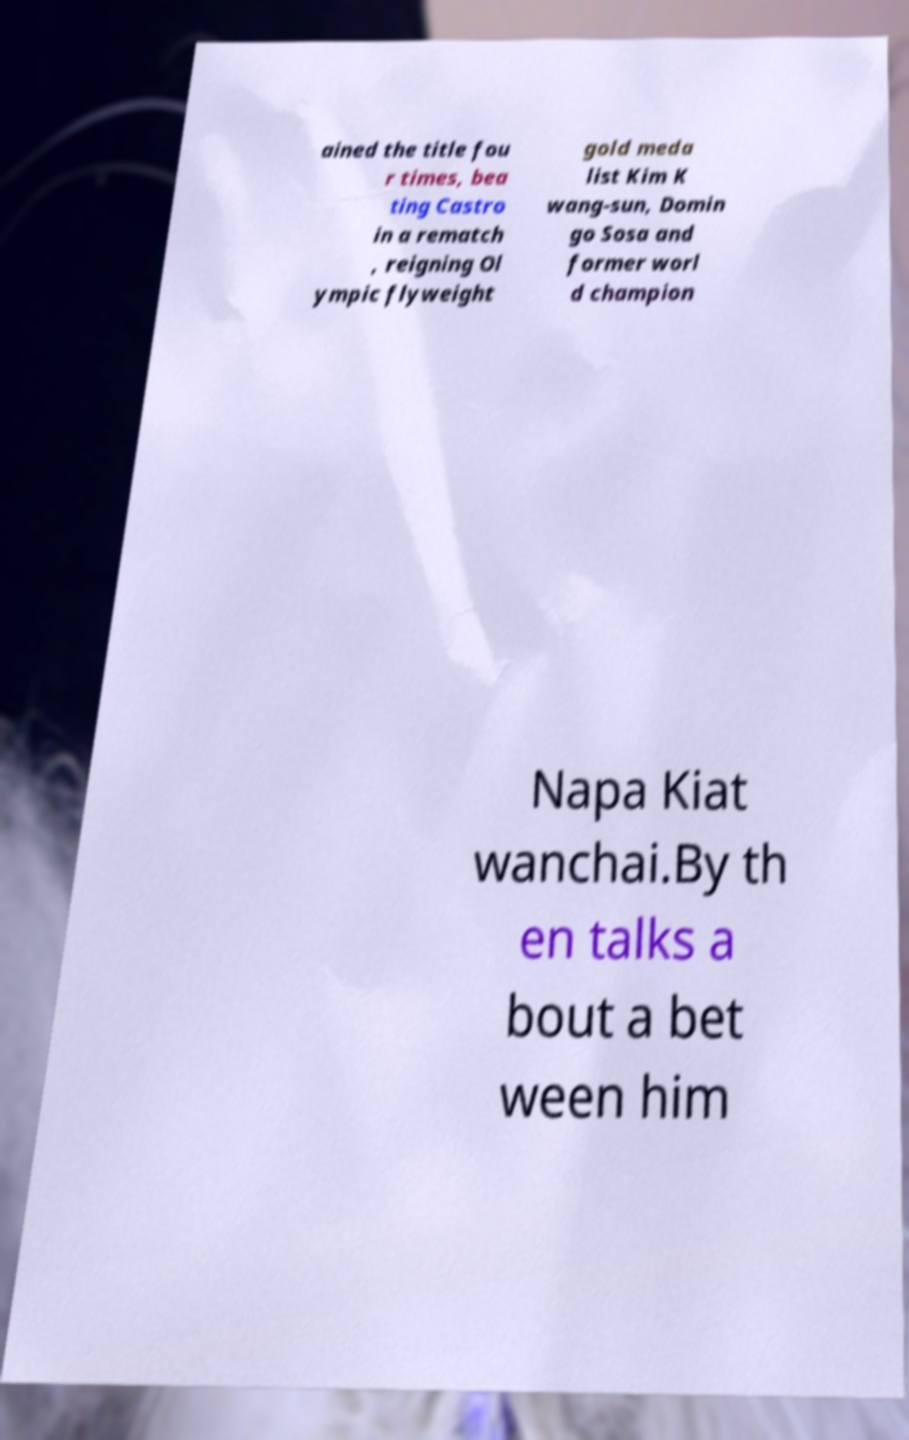Could you assist in decoding the text presented in this image and type it out clearly? ained the title fou r times, bea ting Castro in a rematch , reigning Ol ympic flyweight gold meda list Kim K wang-sun, Domin go Sosa and former worl d champion Napa Kiat wanchai.By th en talks a bout a bet ween him 